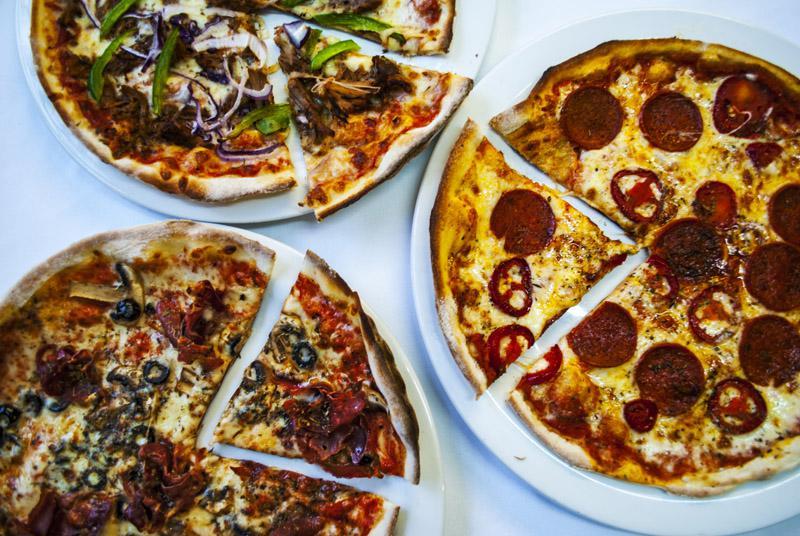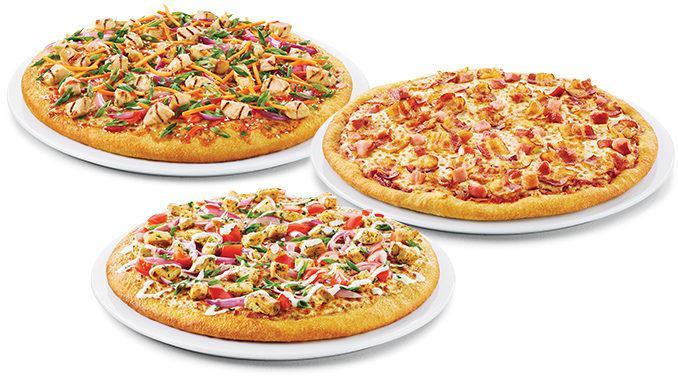The first image is the image on the left, the second image is the image on the right. Given the left and right images, does the statement "At least one pizza has been sliced." hold true? Answer yes or no. Yes. 